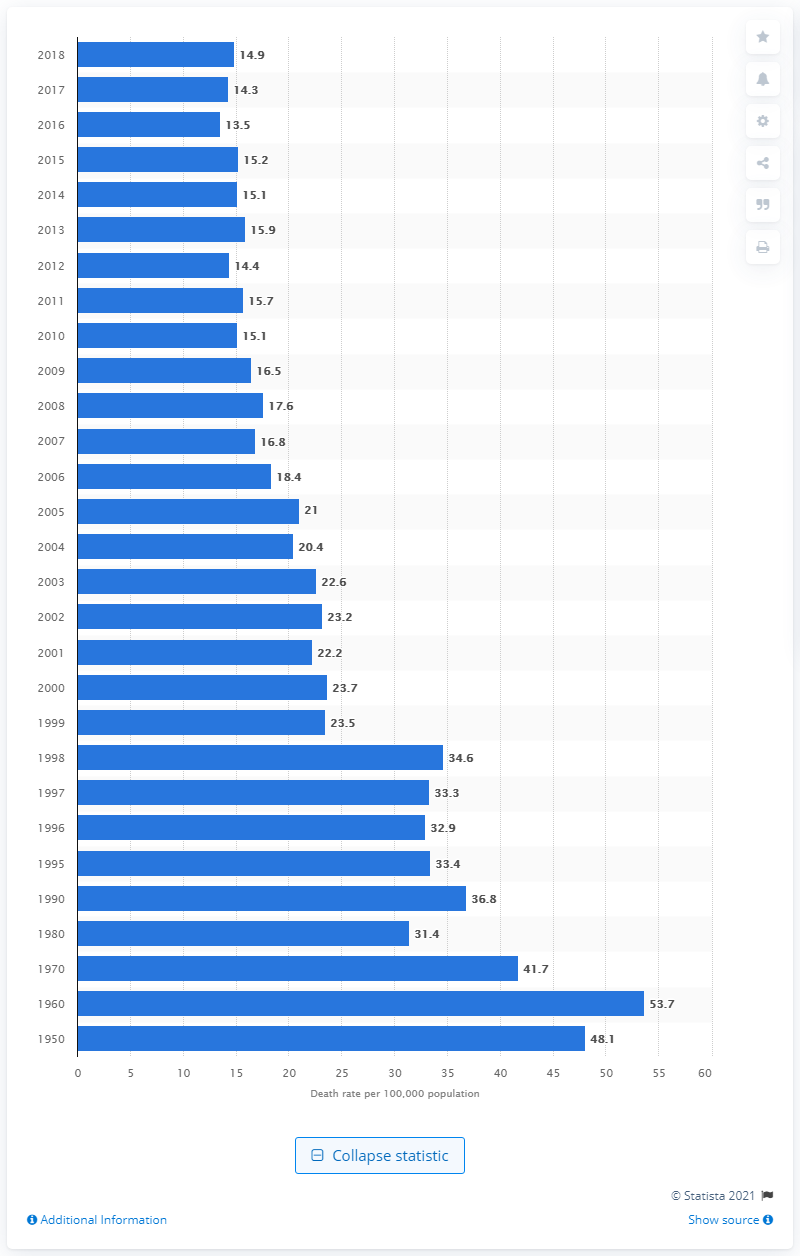Mention a couple of crucial points in this snapshot. Influenza and pneumonia caused 14.9 deaths per 100,000 people in the United States in 2018, according to statistics. 